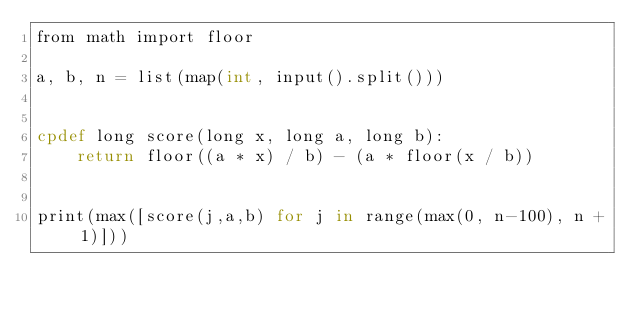<code> <loc_0><loc_0><loc_500><loc_500><_Cython_>from math import floor

a, b, n = list(map(int, input().split()))


cpdef long score(long x, long a, long b):
    return floor((a * x) / b) - (a * floor(x / b))


print(max([score(j,a,b) for j in range(max(0, n-100), n + 1)]))</code> 